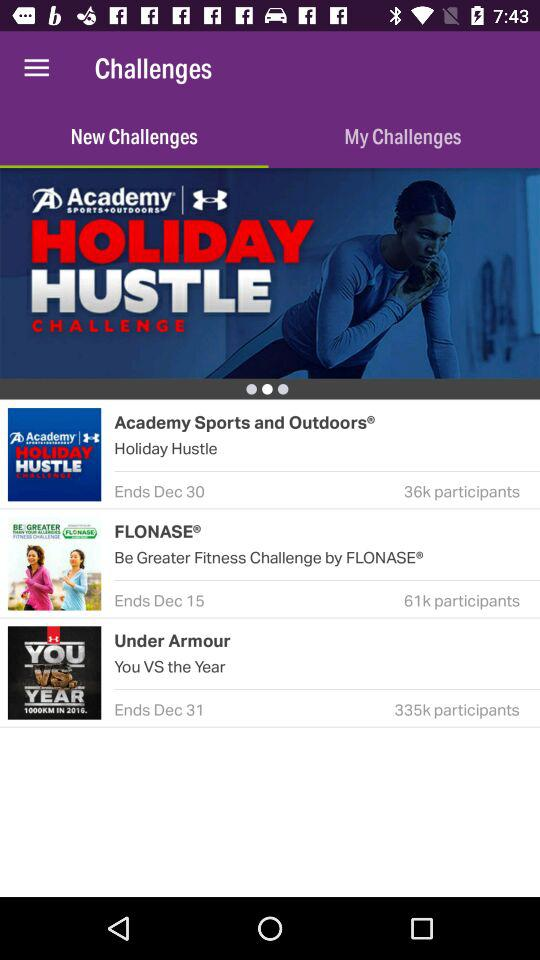How many participants are there in FLONASE? The number of participants in FLONASE is 61k. 